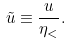<formula> <loc_0><loc_0><loc_500><loc_500>\tilde { u } \equiv \frac { u } { \eta _ { < } } .</formula> 